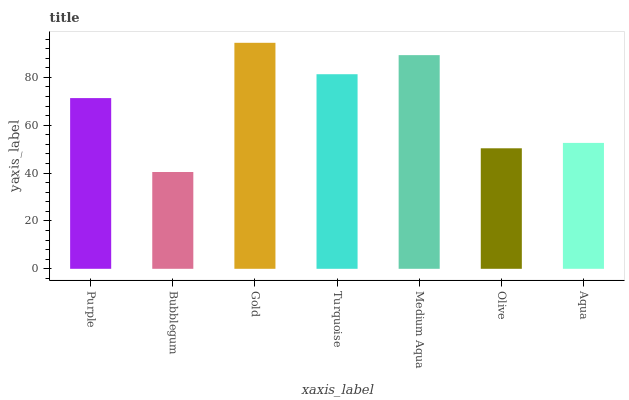Is Bubblegum the minimum?
Answer yes or no. Yes. Is Gold the maximum?
Answer yes or no. Yes. Is Gold the minimum?
Answer yes or no. No. Is Bubblegum the maximum?
Answer yes or no. No. Is Gold greater than Bubblegum?
Answer yes or no. Yes. Is Bubblegum less than Gold?
Answer yes or no. Yes. Is Bubblegum greater than Gold?
Answer yes or no. No. Is Gold less than Bubblegum?
Answer yes or no. No. Is Purple the high median?
Answer yes or no. Yes. Is Purple the low median?
Answer yes or no. Yes. Is Turquoise the high median?
Answer yes or no. No. Is Gold the low median?
Answer yes or no. No. 